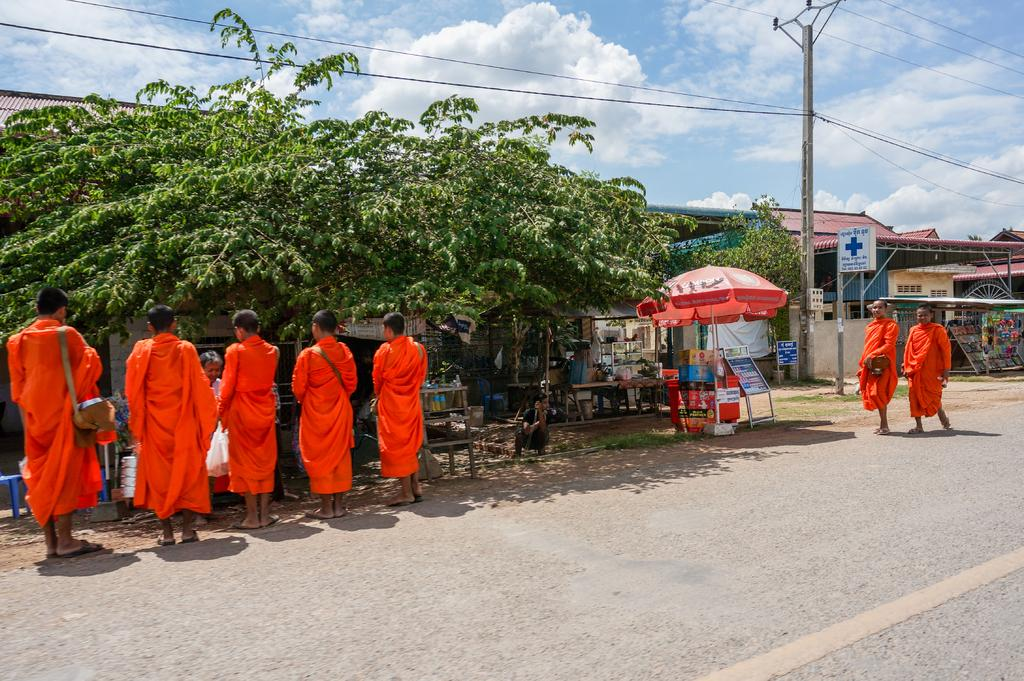Where was the image taken? The image was clicked outside. What can be seen in the middle of the image? There are trees, saints, and shops in the middle of the image. What is visible at the top of the image? The sky is visible at the top of the image. Can you see a bike parked near the shops in the image? There is no bike visible in the image. Is there a harbor with boats in the middle of the image? There is no harbor or boats present in the image. 